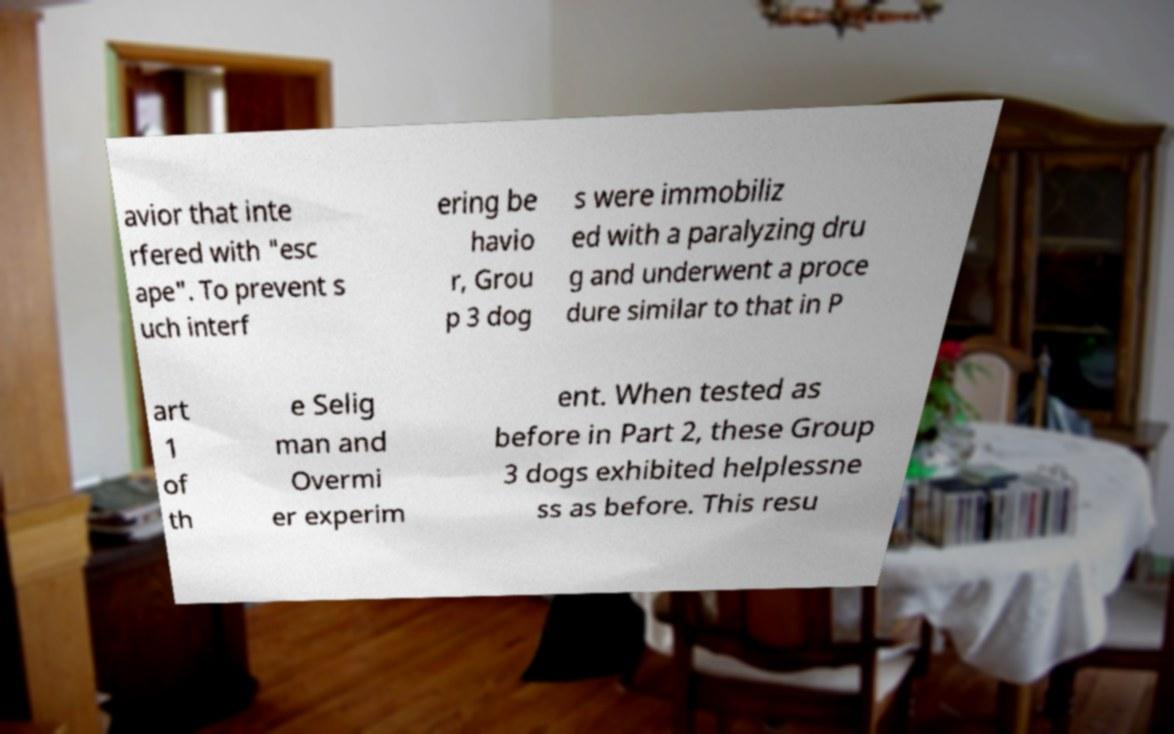Please identify and transcribe the text found in this image. avior that inte rfered with "esc ape". To prevent s uch interf ering be havio r, Grou p 3 dog s were immobiliz ed with a paralyzing dru g and underwent a proce dure similar to that in P art 1 of th e Selig man and Overmi er experim ent. When tested as before in Part 2, these Group 3 dogs exhibited helplessne ss as before. This resu 